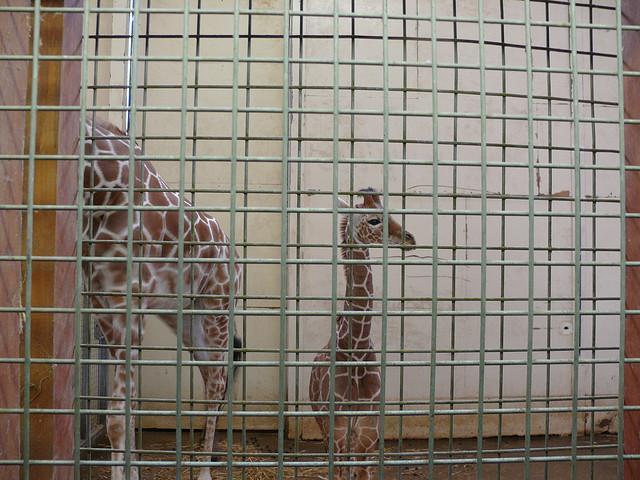How many giraffes are visible?
Give a very brief answer. 2. 